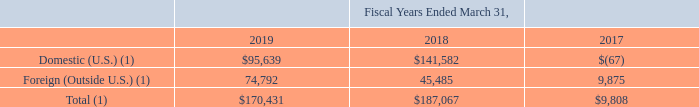Note 11: Income Taxes
The components of income before income taxes and equity income (loss) from equity method investments are as follows (amounts in thousands):
(1) Fiscal years ended March 31, 2018 and 2017 adjusted due to the adoption of ASC 606.
Which years does the table provide information for the components of income before income taxes and equity income (loss) from equity method investments? 2019, 2018, 2017. What was the income from U.S. in 2017?
Answer scale should be: thousand. (67). What was the total income in 2019?
Answer scale should be: thousand. 170,431. What was the change in Foreign income between 2017 and 2018?
Answer scale should be: thousand. 45,485-9,875
Answer: 35610. How many years did Domestic (U.S.) income exceed $100,000 thousand? 2018
Answer: 1. What was the percentage change in total income between 2018 and 2019?
Answer scale should be: percent. (170,431-187,067)/187,067
Answer: -8.89. 